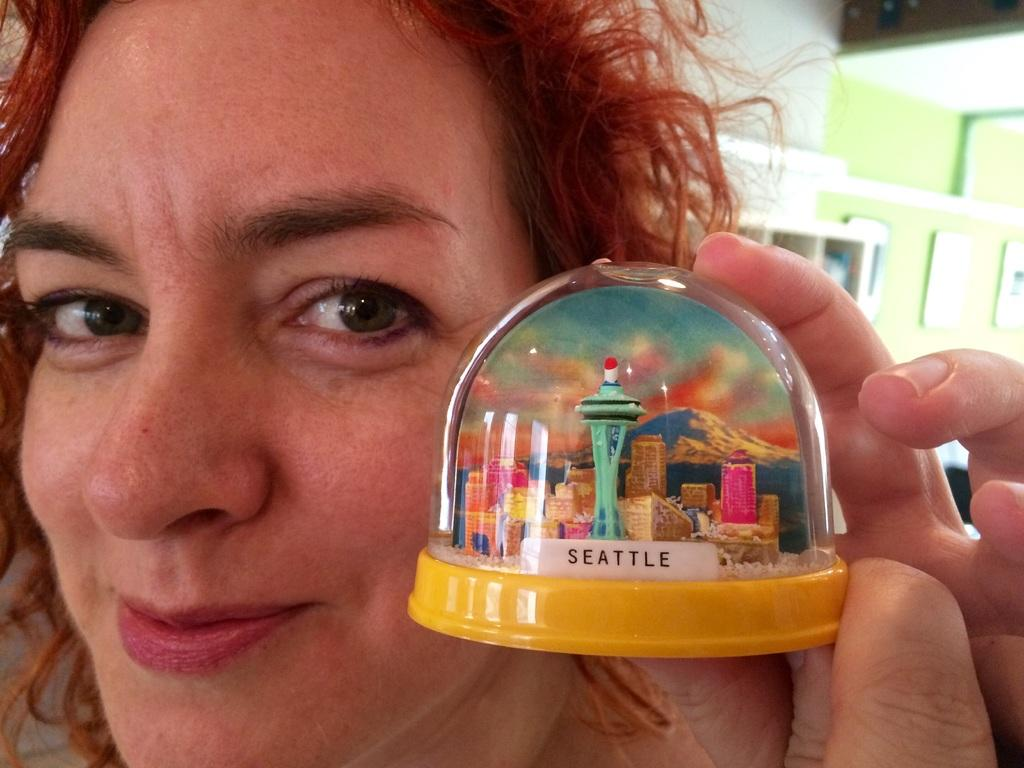<image>
Offer a succinct explanation of the picture presented. A redheaded woman is holding back a yellow-based Seattle snow globe. 